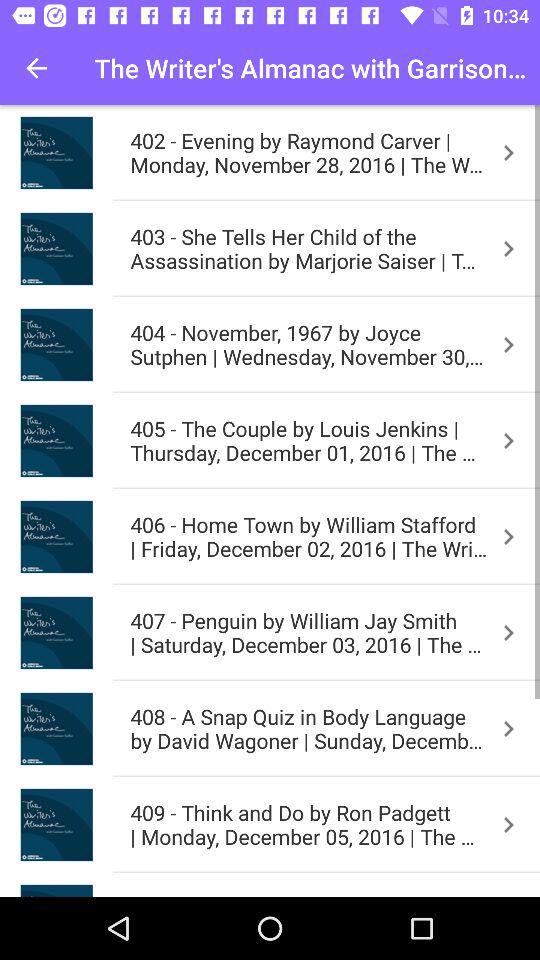What's happened on 3 December 2016?
When the provided information is insufficient, respond with <no answer>. <no answer> 